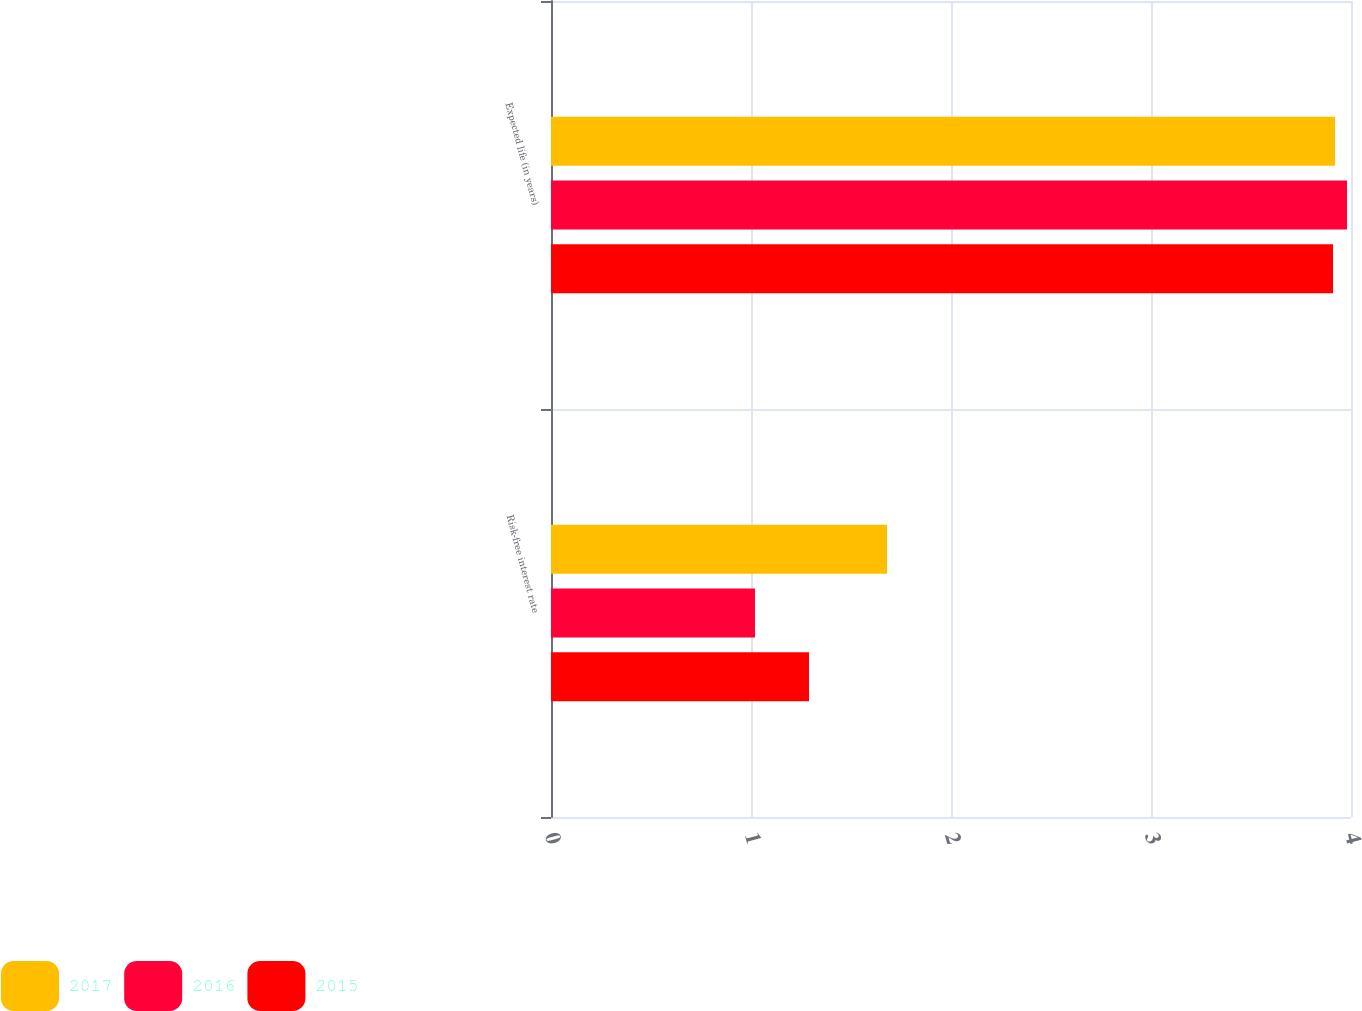<chart> <loc_0><loc_0><loc_500><loc_500><stacked_bar_chart><ecel><fcel>Risk-free interest rate<fcel>Expected life (in years)<nl><fcel>2017<fcel>1.68<fcel>3.92<nl><fcel>2016<fcel>1.02<fcel>3.98<nl><fcel>2015<fcel>1.29<fcel>3.91<nl></chart> 